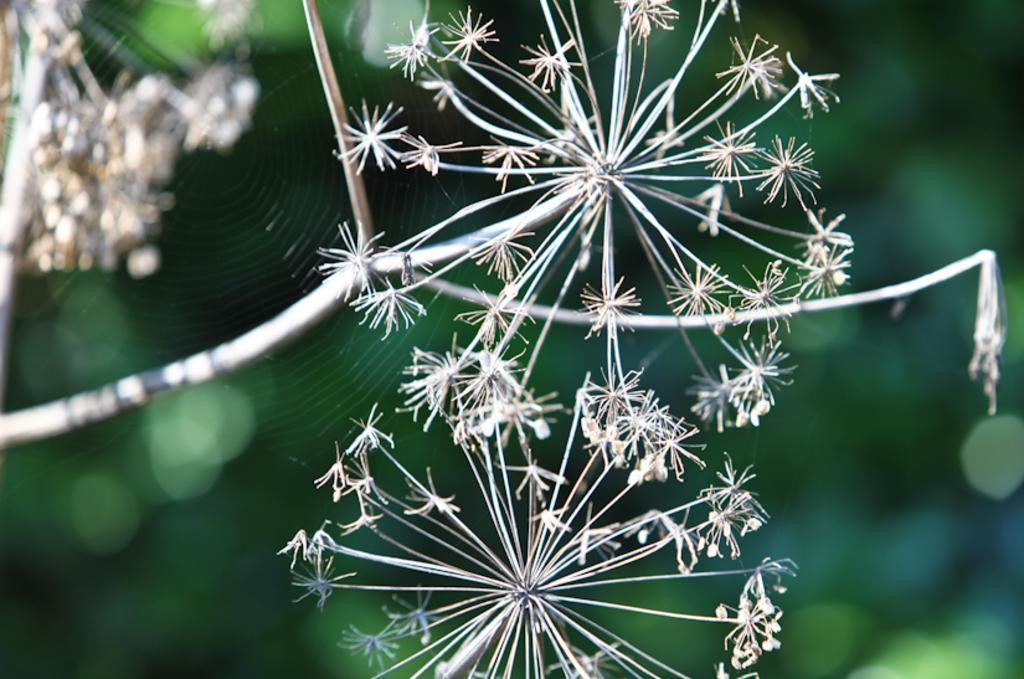Can you describe this image briefly? In this image I can see flowers and net of the spider visible. 